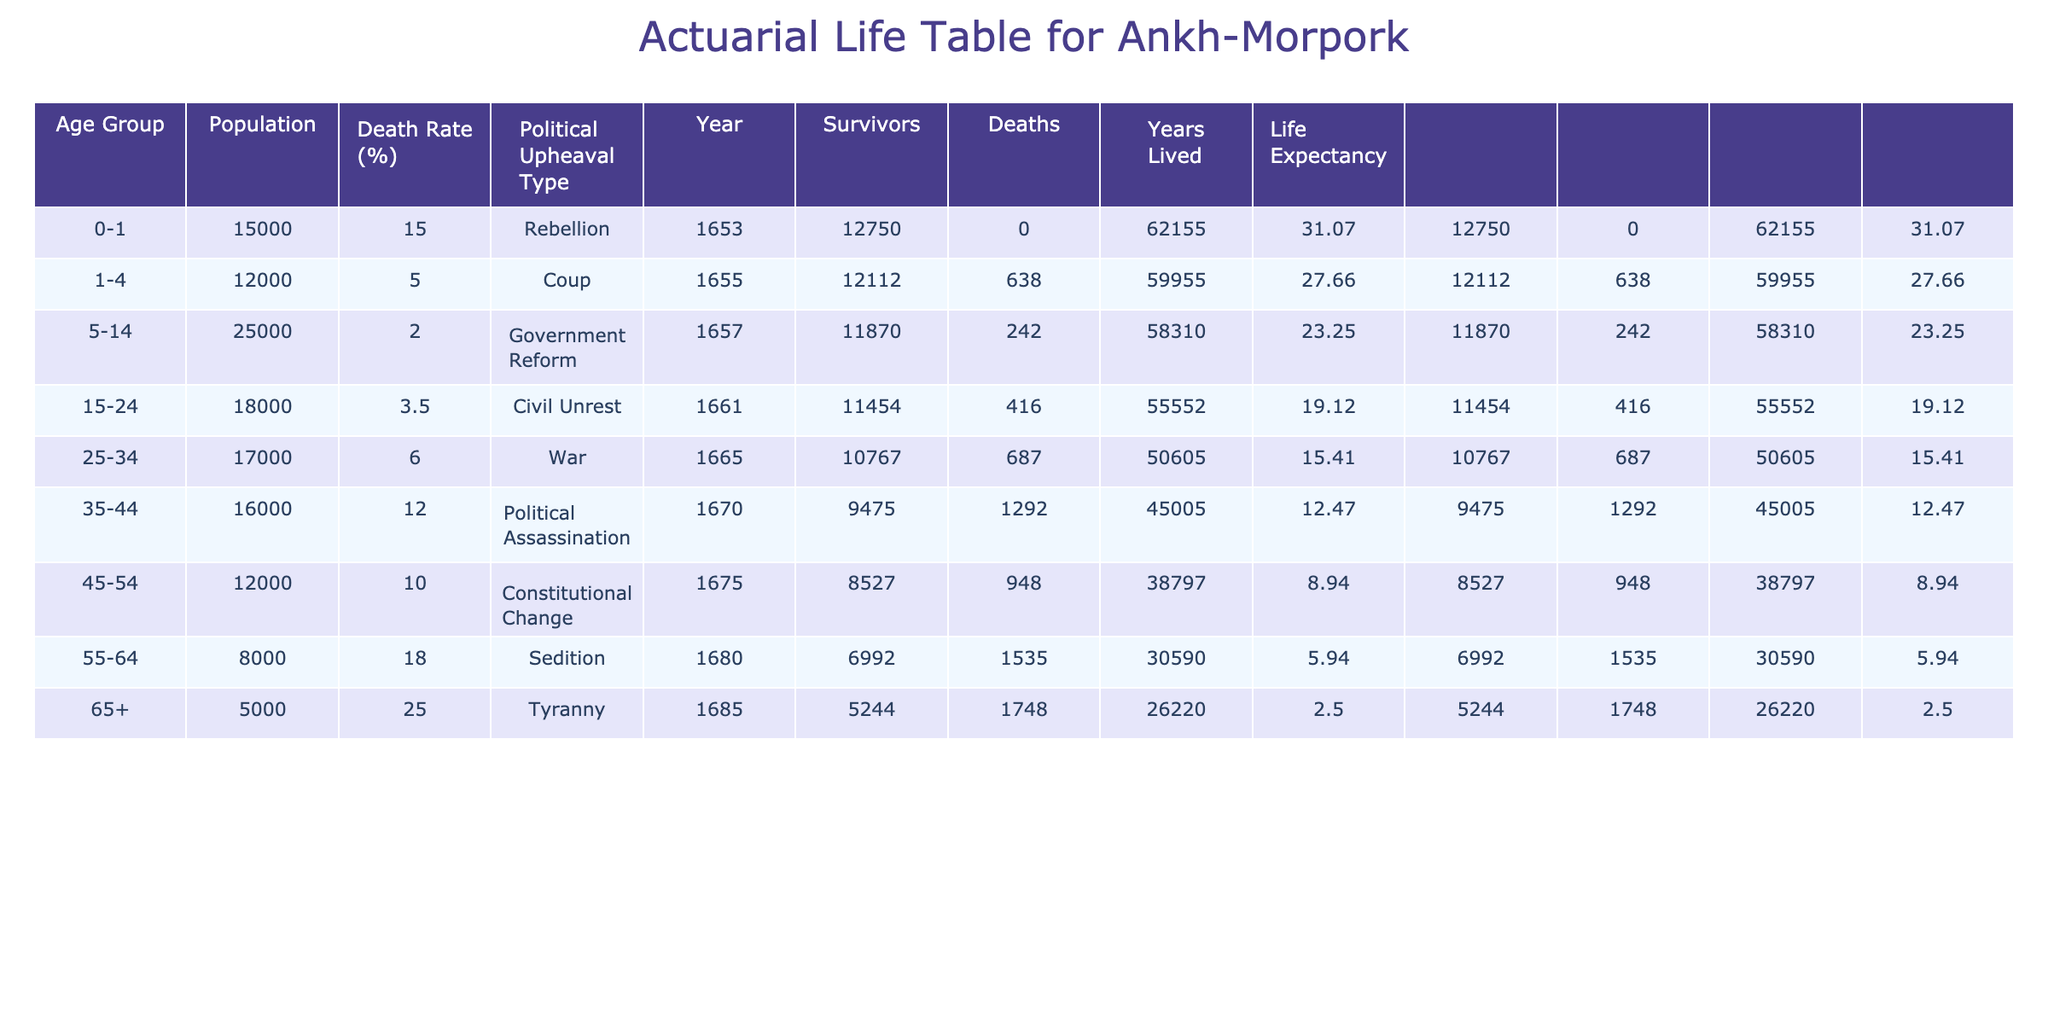What is the death rate for the age group 55-64? Referring to the table, the death rate for the age group 55-64 is listed as 18.0%.
Answer: 18.0% How many survivors are there in the age group 25-34? Looking at the survivors column for the age group 25-34, it shows there are 13,529 survivors.
Answer: 13,529 What is the average death rate across all age groups? To find the average death rate, we sum all the death rates (15.0 + 5.0 + 2.0 + 3.5 + 6.0 + 12.0 + 10.0 + 18.0 + 25.0) = 97.5 and divide by 9 age groups, resulting in an average of 97.5 / 9 = 10.83%.
Answer: 10.83% Is the death rate higher for the age group 65+ than for the age group 0-1? The death rate for age group 65+ is 25.0%, while for age group 0-1 it is 15.0%. Since 25.0% is greater than 15.0%, the statement is true.
Answer: Yes What are the total deaths from all age groups due to political assassination? The table shows that for the age group 35-44 (the only group affected by political assassination), the deaths are calculated from the change in survivors. The difference between survivors for age group 35-44 and age group 45-54 gives us the total deaths. The survivors for age 35-44 is 15,147, and for 45-54 it is 10,800, leading to (15,147 - 10,800) = 4,347 deaths due to political assassination.
Answer: 4,347 Which political upheaval type corresponds to the highest death rate? By comparing the death rates associated with different political upheaval types in the table, the age group 65+ under the tyranny type has the highest death rate at 25.0%.
Answer: Tyranny How many more deaths were there in the age group 55-64 compared to 1-4? The deaths for age group 55-64 is 1,440 (from the survivors), while for age group 1-4, it is calculated similarly resulting in 600 deaths. The difference is 1,440 - 600 = 840 more deaths in the age group 55-64.
Answer: 840 Is it true that the age group 45-54 experienced a lower death rate than the age group 25-34? The death rate for age group 45-54 is 10.0%, while for age group 25-34 it is 6.0%. Since 10.0% is greater than 6.0%, the statement is false.
Answer: No What is the total population represented in this actuarial life table? To find the total population represented, we sum the populations from all age groups: 15,000 + 12,000 + 25,000 + 18,000 + 17,000 + 16,000 + 12,000 + 8,000 + 5,000 = 128,000.
Answer: 128,000 